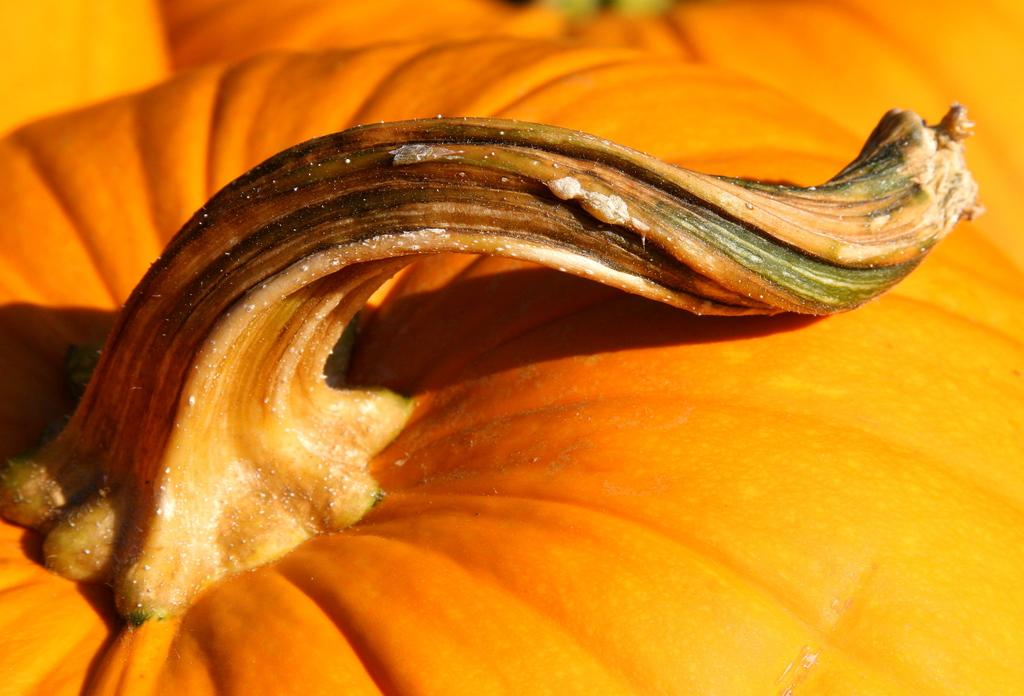What type of vegetable is present in the image? There are pumpkins in the image. What type of bell can be seen hanging from the pumpkin in the image? There is no bell present in the image, and the pumpkin is not depicted as having any hooks or attachments. 